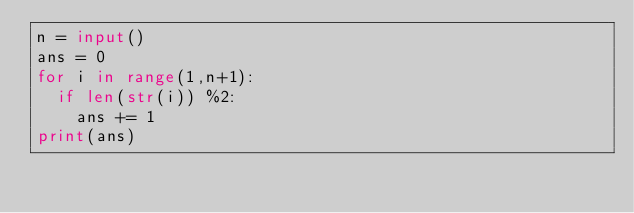<code> <loc_0><loc_0><loc_500><loc_500><_Python_>n = input()
ans = 0
for i in range(1,n+1):
  if len(str(i)) %2:
    ans += 1
print(ans)</code> 